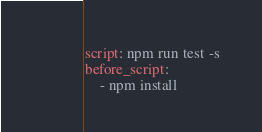<code> <loc_0><loc_0><loc_500><loc_500><_YAML_>script: npm run test -s
before_script:
    - npm install
</code> 